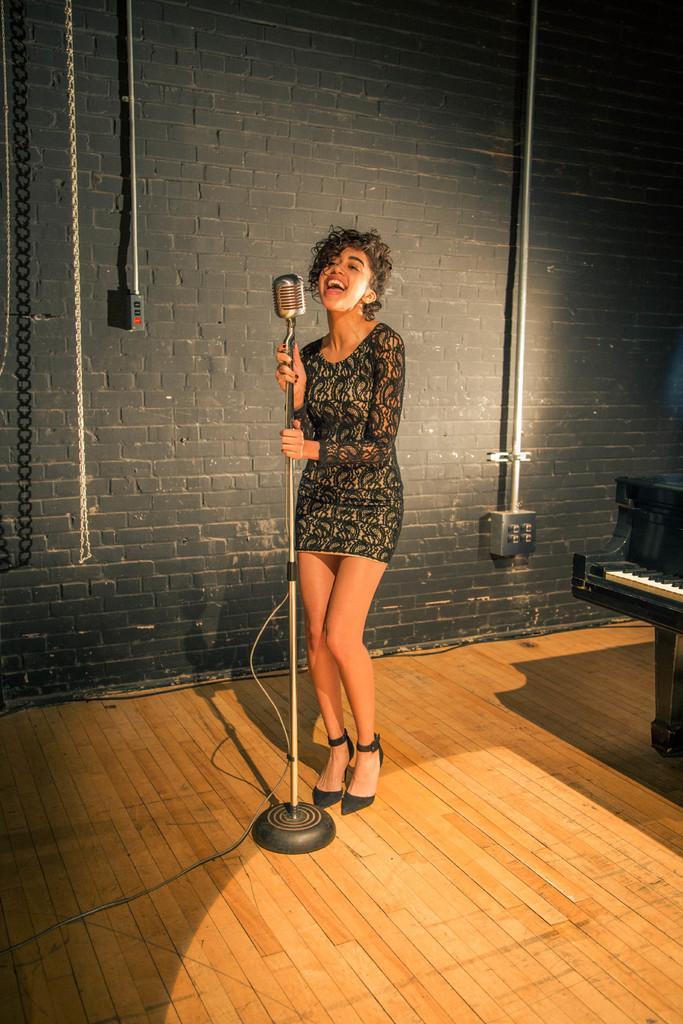Please provide a concise description of this image. Here we can see a lady standing with a microphone in front of her, she is holding the microphone and singing, behind her there is a brick wall and at the right side we can see a piano 